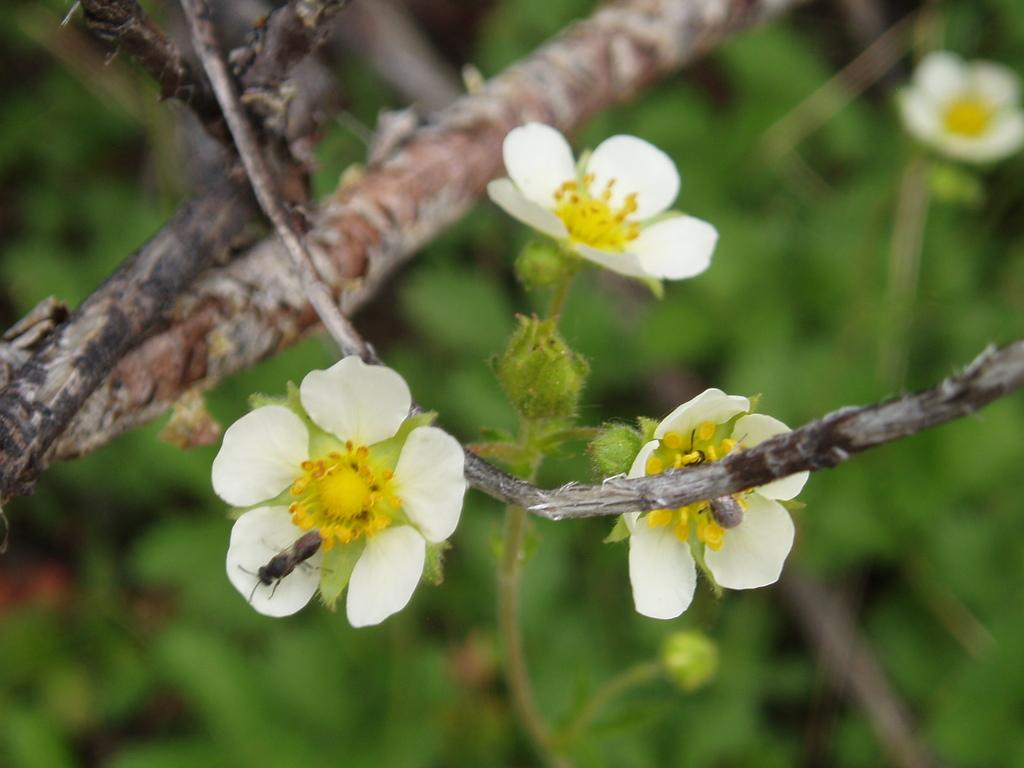How many bees are in the image? There are two bees in the image. Where are the bees located in the image? The bees are on the flowers of a tree. What can be seen in the background of the image? There are flowers and trees in the background of the image. What type of popcorn can be seen in the image? There is no popcorn present in the image. Is there a jail visible in the image? There is no jail present in the image. What type of furniture is in the image? The image does not show any furniture, such as a table. 